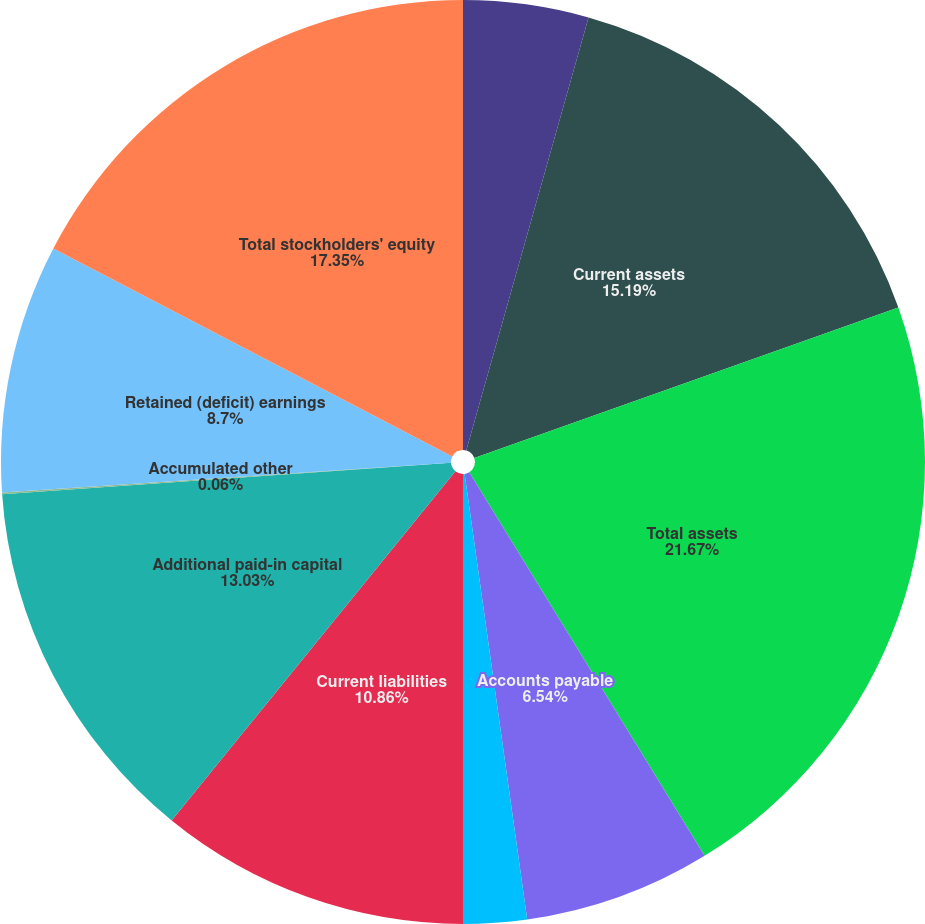Convert chart to OTSL. <chart><loc_0><loc_0><loc_500><loc_500><pie_chart><fcel>Accounts receivable<fcel>Current assets<fcel>Total assets<fcel>Accounts payable<fcel>Other current liabilities<fcel>Current liabilities<fcel>Additional paid-in capital<fcel>Accumulated other<fcel>Retained (deficit) earnings<fcel>Total stockholders' equity<nl><fcel>4.38%<fcel>15.19%<fcel>21.67%<fcel>6.54%<fcel>2.22%<fcel>10.86%<fcel>13.03%<fcel>0.06%<fcel>8.7%<fcel>17.35%<nl></chart> 